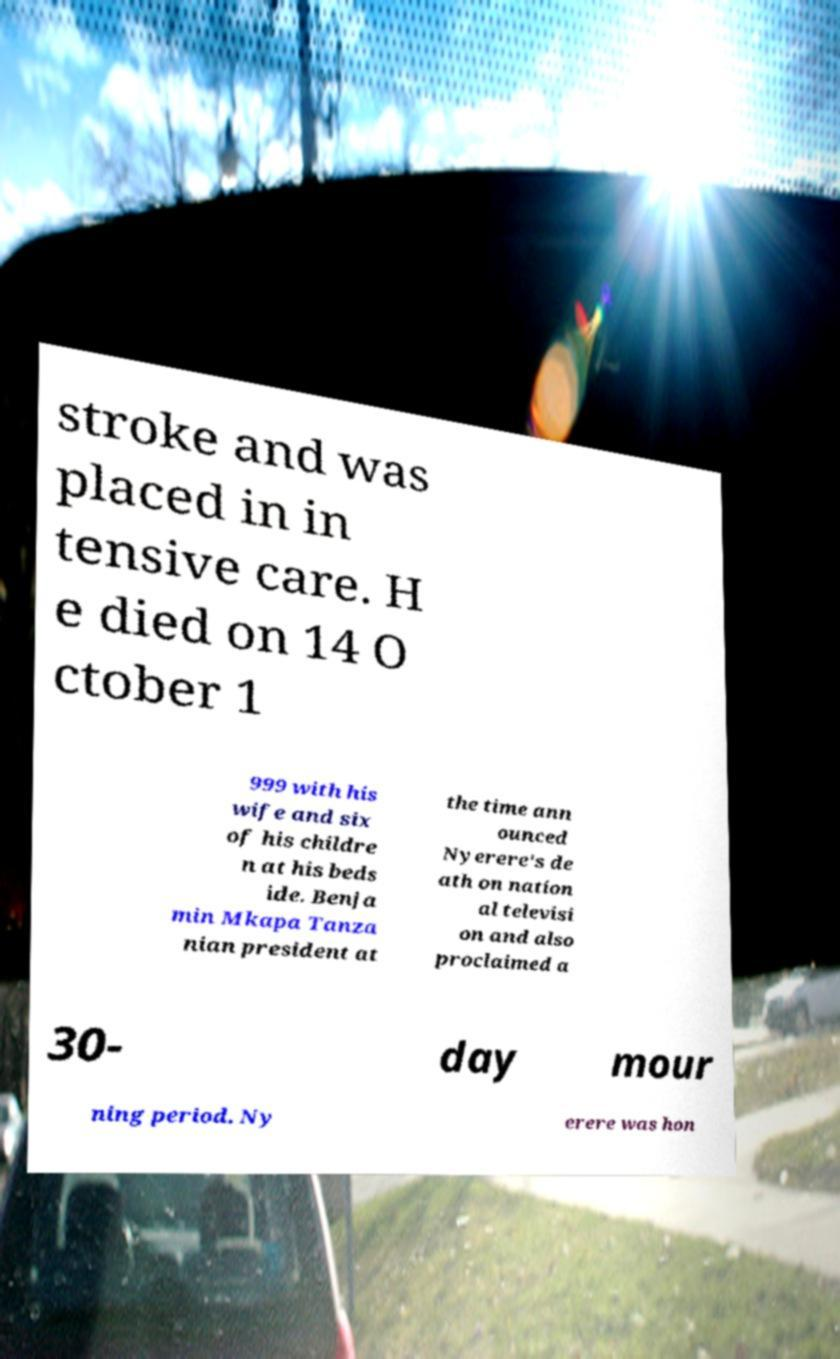For documentation purposes, I need the text within this image transcribed. Could you provide that? stroke and was placed in in tensive care. H e died on 14 O ctober 1 999 with his wife and six of his childre n at his beds ide. Benja min Mkapa Tanza nian president at the time ann ounced Nyerere's de ath on nation al televisi on and also proclaimed a 30- day mour ning period. Ny erere was hon 